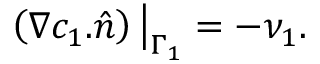Convert formula to latex. <formula><loc_0><loc_0><loc_500><loc_500>\left ( \nabla c _ { 1 } . \hat { n } \right ) \Big | _ { \Gamma _ { 1 } } = - \nu _ { 1 } .</formula> 